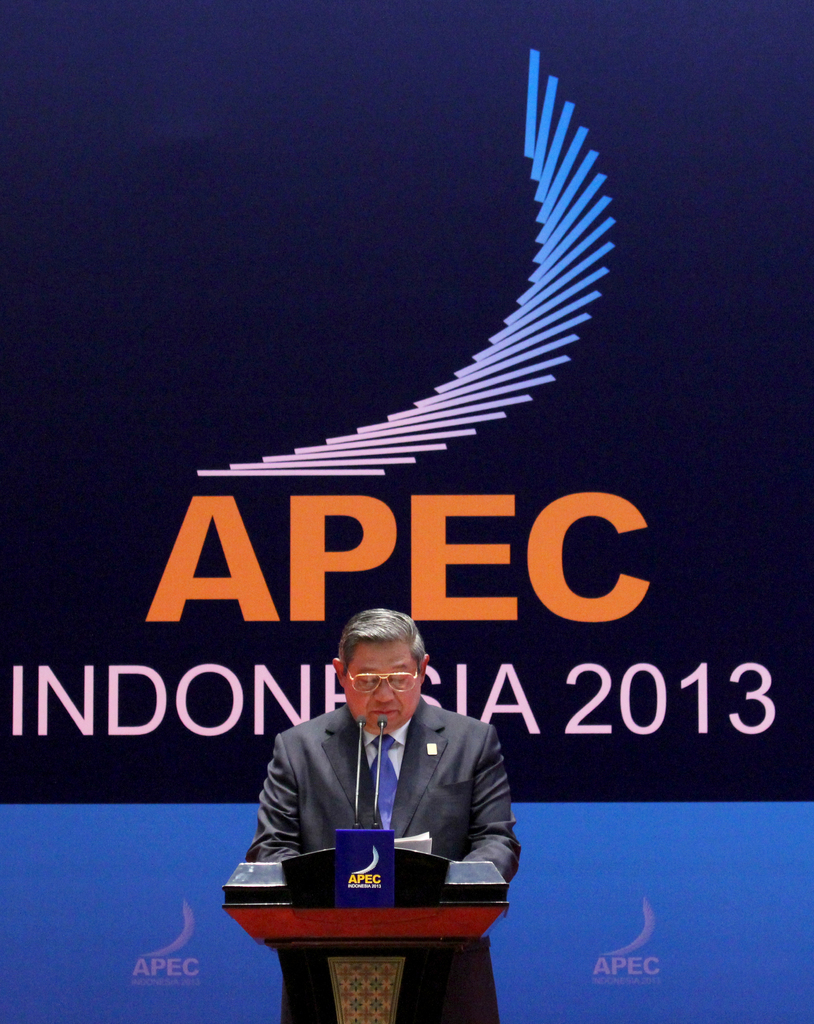Describe the following image. The photograph captures a distinguished man giving a speech at the APEC Indonesia 2013 conference. He stands at a dark wooden podium adorned with the APEC logo, situated against a backdrop featuring an enlarged APEC logo and the striking blue text stating 'APEC INDONESIA 2013'. His attire, a formal suit, and the glasses he sports add to the gravity of the event he is addressing. The environment indicates a high-profile international meeting focusing on vital regional economic and political issues, with the speaker playing a crucial role in the proceedings. 